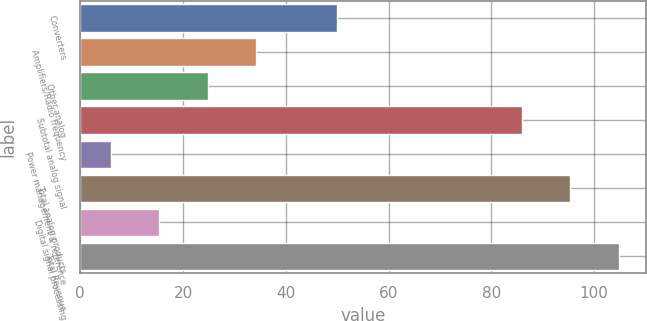<chart> <loc_0><loc_0><loc_500><loc_500><bar_chart><fcel>Converters<fcel>Amplifiers/Radio frequency<fcel>Other analog<fcel>Subtotal analog signal<fcel>Power management & reference<fcel>Total analog products<fcel>Digital signal processing<fcel>Total Revenue<nl><fcel>50<fcel>34.2<fcel>24.8<fcel>86<fcel>6<fcel>95.4<fcel>15.4<fcel>104.8<nl></chart> 